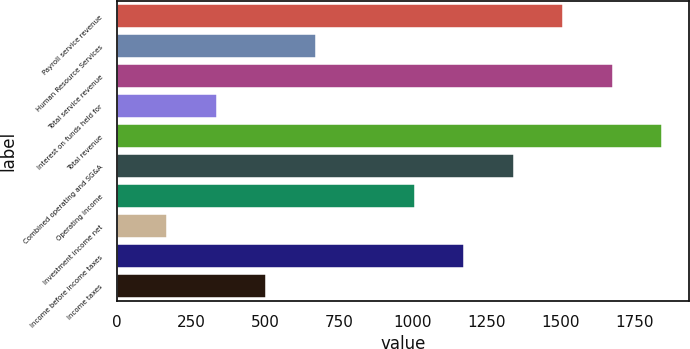Convert chart to OTSL. <chart><loc_0><loc_0><loc_500><loc_500><bar_chart><fcel>Payroll service revenue<fcel>Human Resource Services<fcel>Total service revenue<fcel>Interest on funds held for<fcel>Total revenue<fcel>Combined operating and SG&A<fcel>Operating income<fcel>Investment income net<fcel>Income before income taxes<fcel>Income taxes<nl><fcel>1507.28<fcel>670.58<fcel>1674.62<fcel>335.9<fcel>1841.96<fcel>1339.94<fcel>1005.26<fcel>168.56<fcel>1172.6<fcel>503.24<nl></chart> 